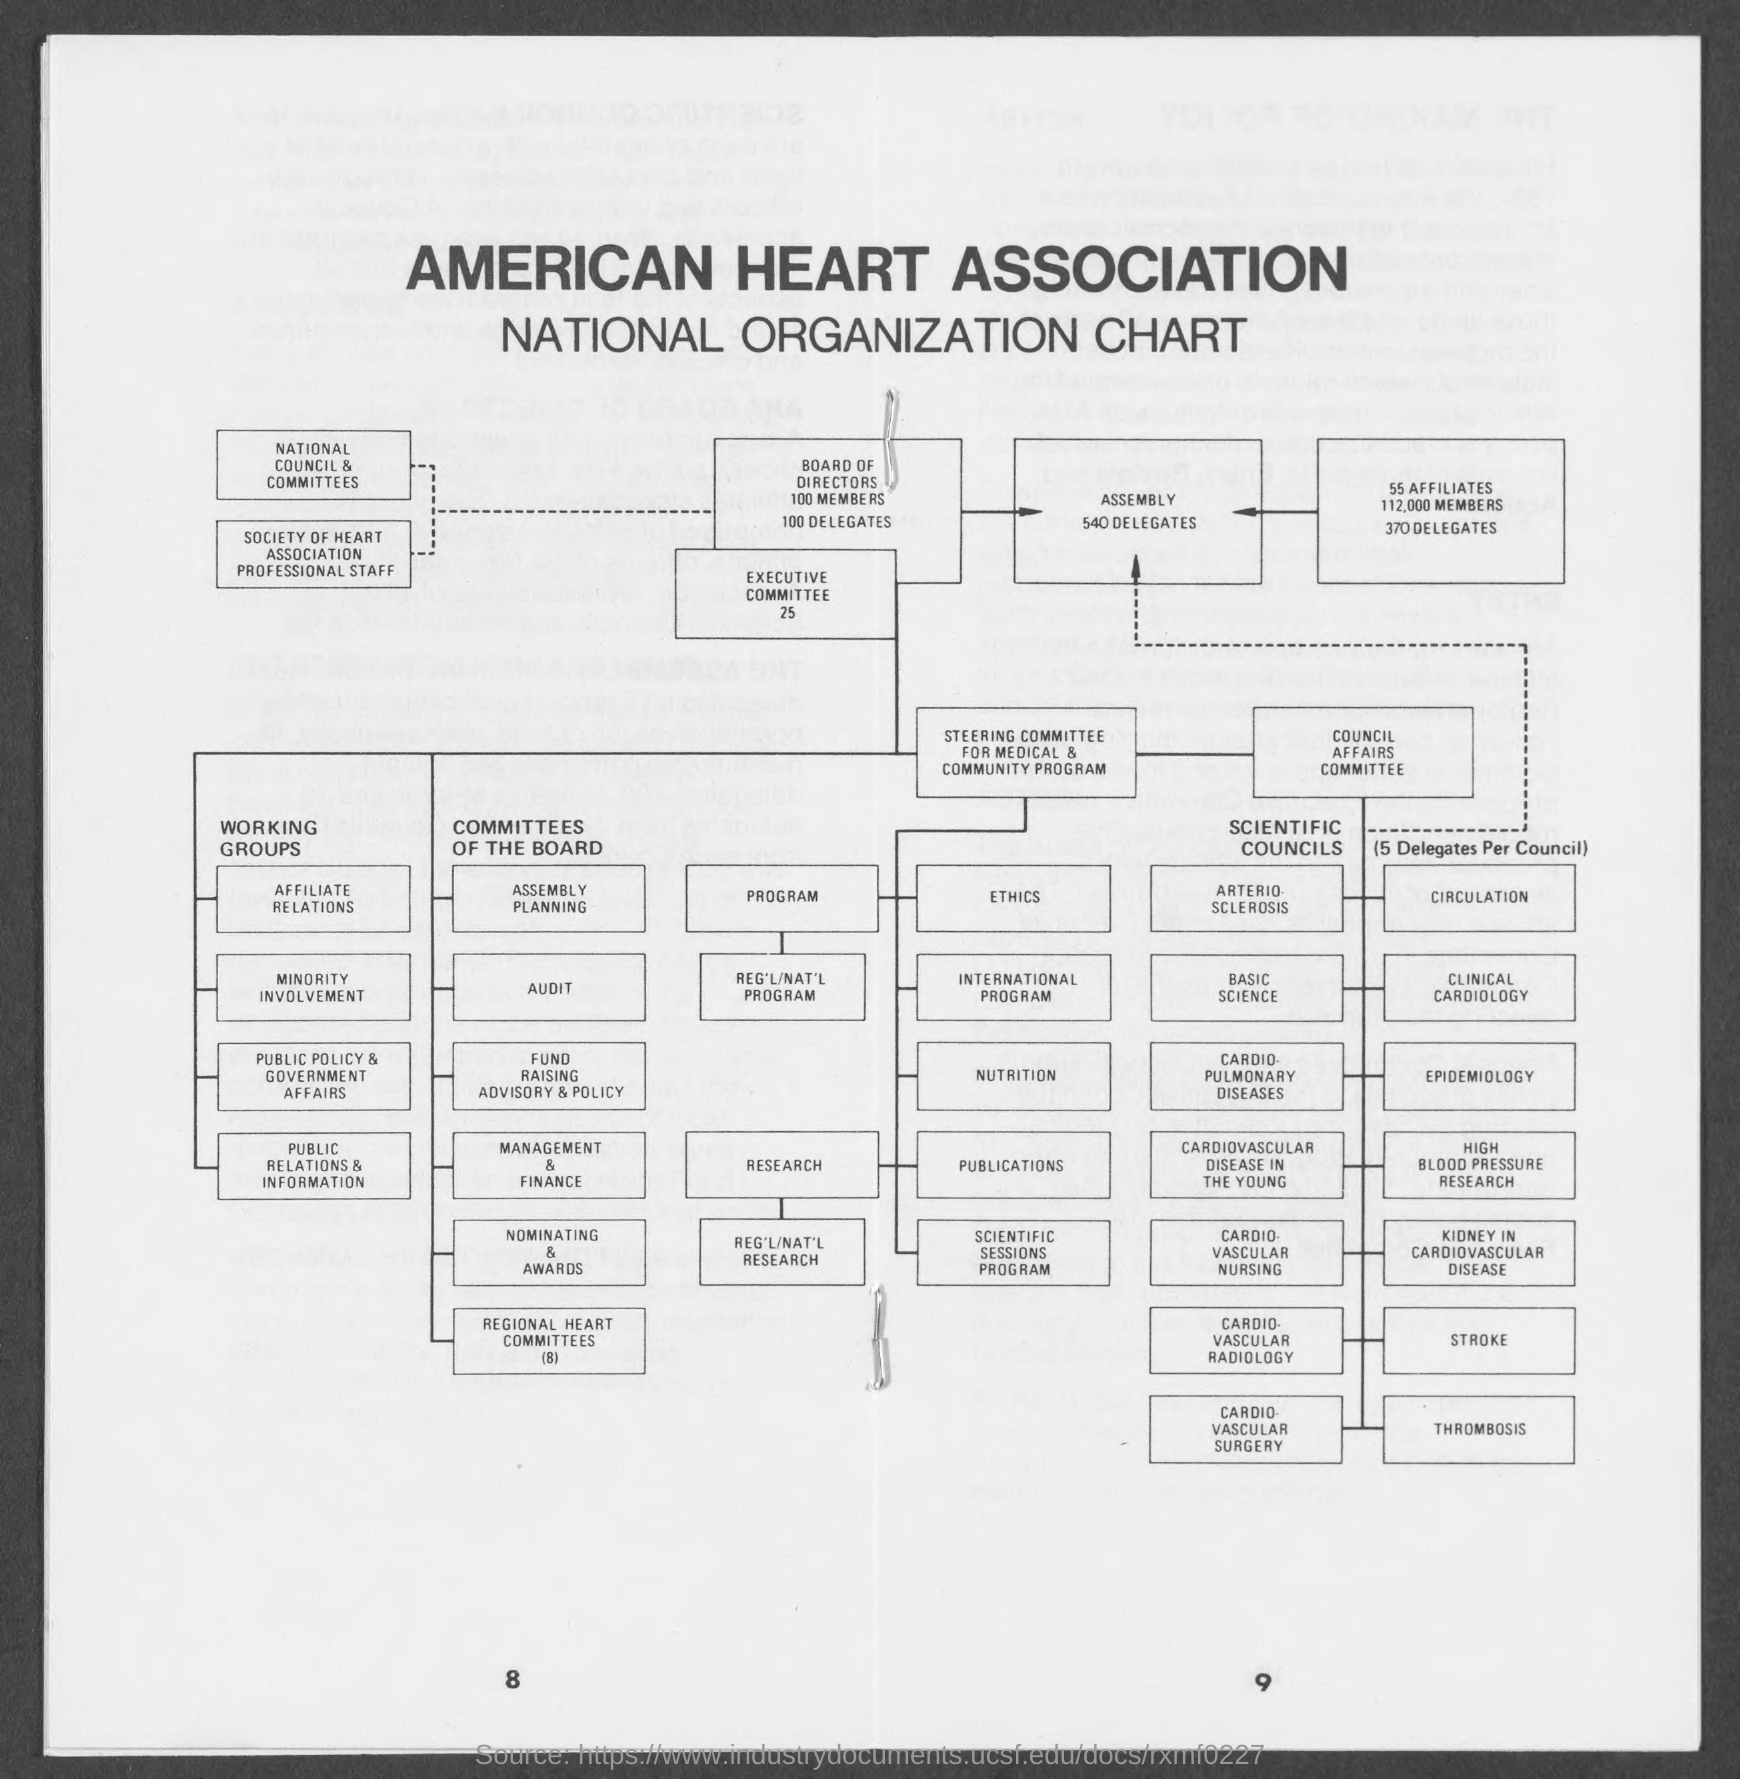What is the number at bottom left page?
Offer a very short reply. 8. What is the number at bottom right page?
Offer a terse response. 9. 